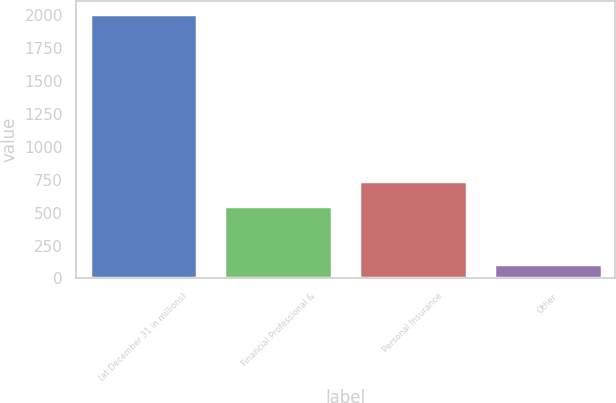Convert chart. <chart><loc_0><loc_0><loc_500><loc_500><bar_chart><fcel>(at December 31 in millions)<fcel>Financial Professional &<fcel>Personal Insurance<fcel>Other<nl><fcel>2006<fcel>551<fcel>741<fcel>106<nl></chart> 